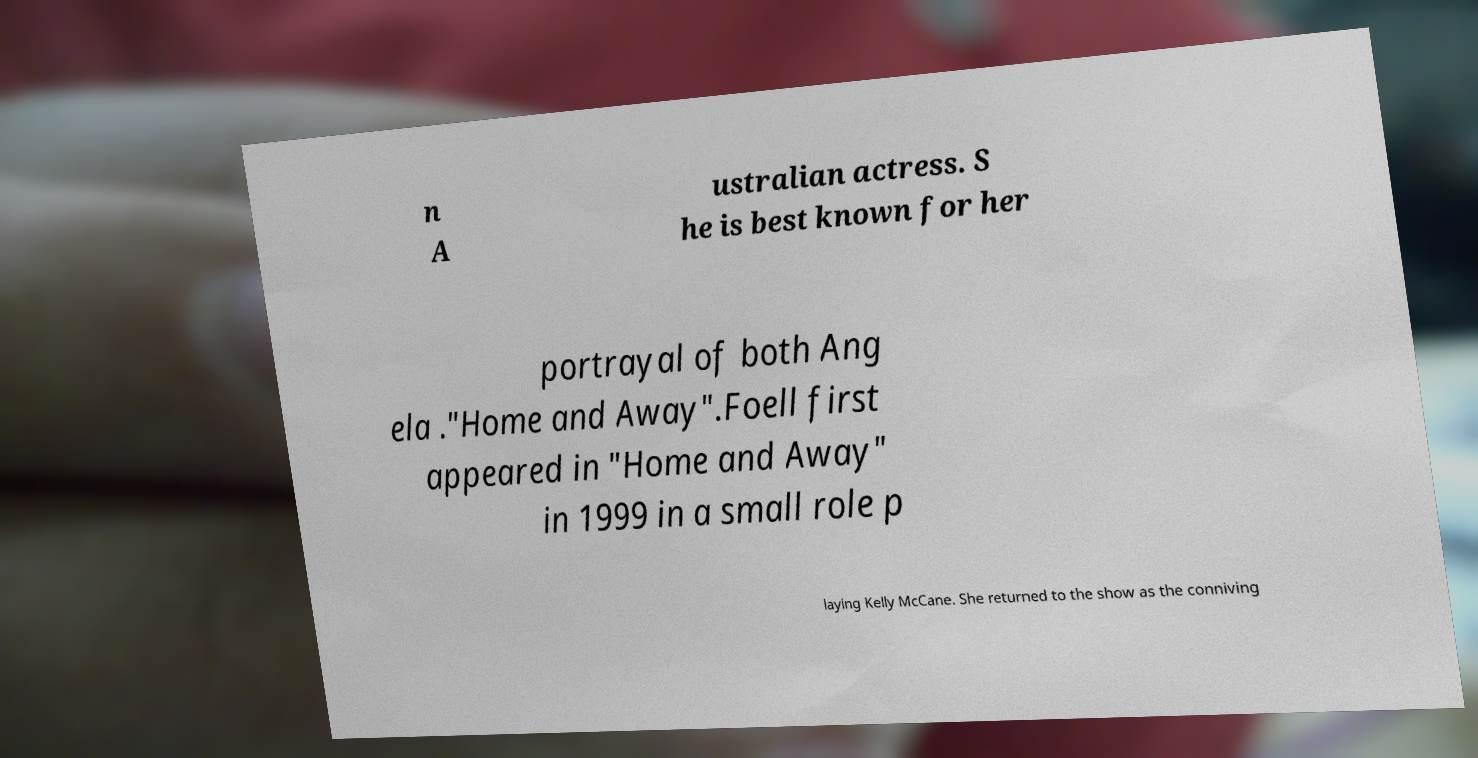Please identify and transcribe the text found in this image. n A ustralian actress. S he is best known for her portrayal of both Ang ela ."Home and Away".Foell first appeared in "Home and Away" in 1999 in a small role p laying Kelly McCane. She returned to the show as the conniving 